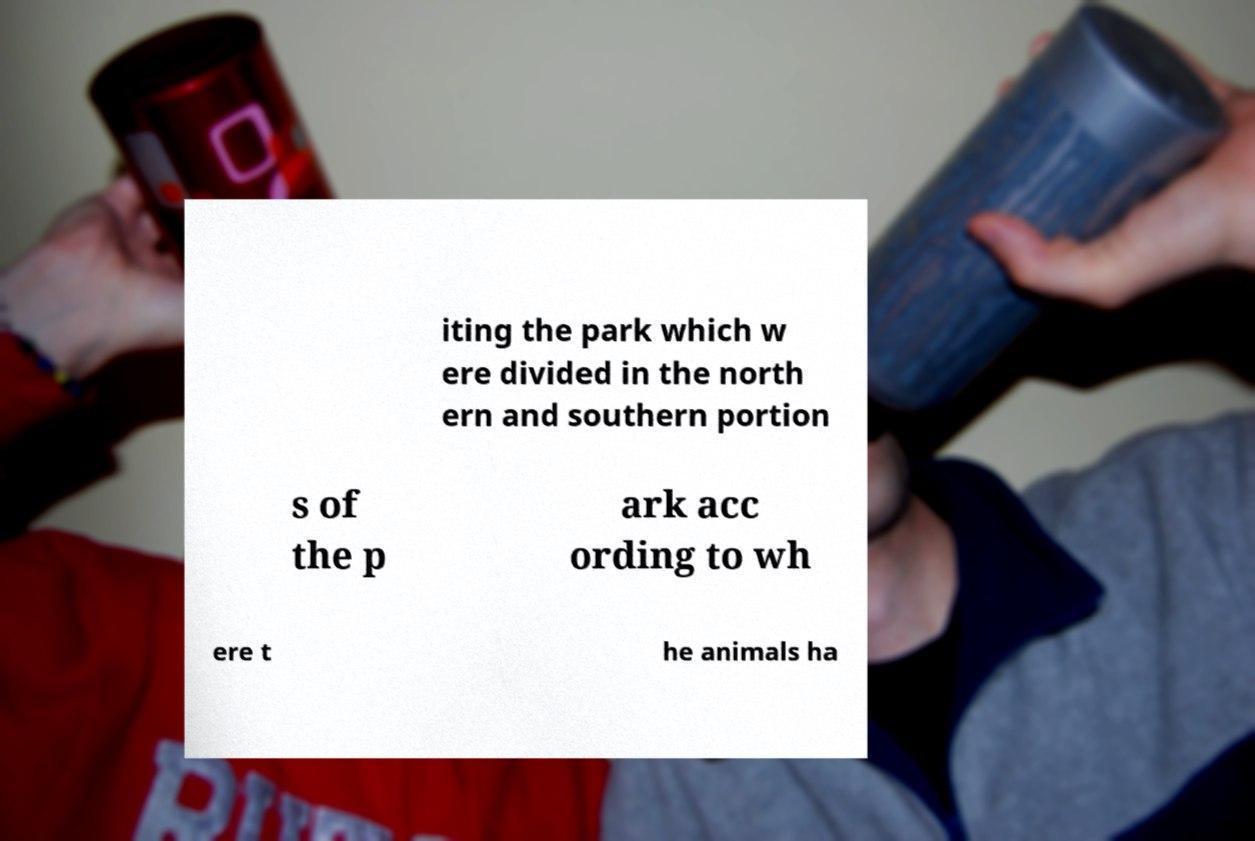Could you assist in decoding the text presented in this image and type it out clearly? iting the park which w ere divided in the north ern and southern portion s of the p ark acc ording to wh ere t he animals ha 